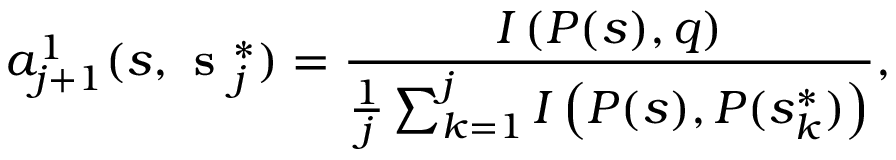<formula> <loc_0><loc_0><loc_500><loc_500>a _ { j + 1 } ^ { 1 } ( s , s _ { j } ^ { * } ) = \frac { I \left ( P ( s ) , q \right ) } { \frac { 1 } { j } \sum _ { k = 1 } ^ { j } I \left ( P ( s ) , P ( s _ { k } ^ { * } ) \right ) } ,</formula> 